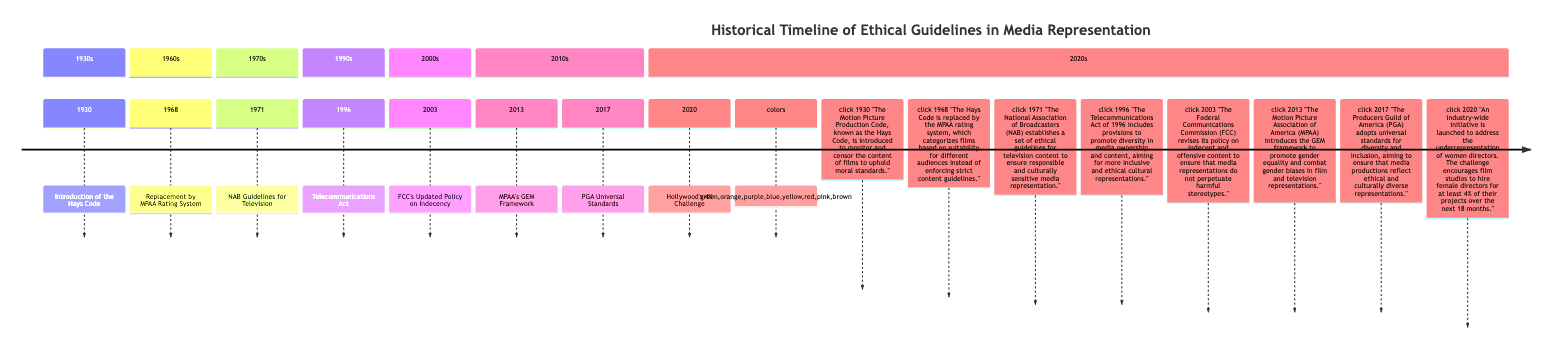What year did the Hays Code get introduced? The timeline indicates the Hays Code was introduced in 1930, listing it in the section for the 1930s.
Answer: 1930 What event replaced the Hays Code? According to the timeline, the Hays Code was replaced by the MPAA rating system in 1968, as stated in the section for the 1960s.
Answer: MPAA Rating System How many events are listed in the timeline? By counting the individual events in each section of the timeline, there are eight distinct events included.
Answer: 8 What does the acronym NAB stand for? The description in the timeline states that the National Association of Broadcasters (NAB) establishes guidelines for television, clearly indicating what NAB stands for.
Answer: National Association of Broadcasters Which event aims to improve gender representation in film and television? The introduction of the MPAA’s Gender Equality in Media (GEM) framework in 2013 specifically focuses on promoting gender equality in media representation.
Answer: MPAA’s GEM Framework When did Hollywood's 4% Challenge begin? The timeline shows that the Hollywood's 4% Challenge was launched in 2020, indicating the start year for this initiative.
Answer: 2020 What was the main focus of the Telecommunications Act of 1996? The timeline states that the act was aimed at promoting diversity in media ownership and content, ensuring more inclusive cultural representations.
Answer: Diversity in media ownership and content What organization adopted universal standards for diversity and inclusion in 2017? The description in the timeline indicates that the Producers Guild of America (PGA) adopted these universal standards for diversity and inclusion.
Answer: Producers Guild of America Which decade did the development of guidelines for television programming occur? The timeline shows that the guidelines were established in 1971, placing this event in the 1970s section of the timeline.
Answer: 1970s 